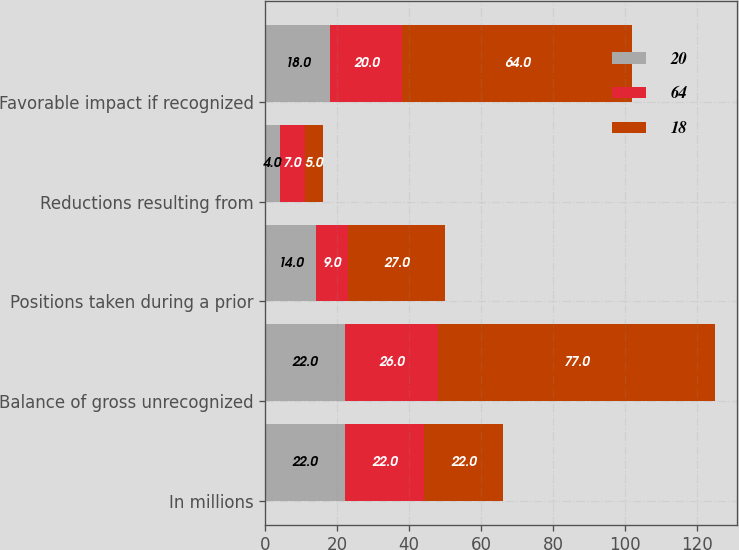Convert chart to OTSL. <chart><loc_0><loc_0><loc_500><loc_500><stacked_bar_chart><ecel><fcel>In millions<fcel>Balance of gross unrecognized<fcel>Positions taken during a prior<fcel>Reductions resulting from<fcel>Favorable impact if recognized<nl><fcel>20<fcel>22<fcel>22<fcel>14<fcel>4<fcel>18<nl><fcel>64<fcel>22<fcel>26<fcel>9<fcel>7<fcel>20<nl><fcel>18<fcel>22<fcel>77<fcel>27<fcel>5<fcel>64<nl></chart> 